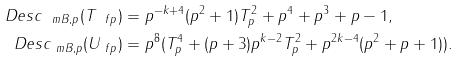<formula> <loc_0><loc_0><loc_500><loc_500>\ D e s c _ { \ m B , p } ( T _ { \ f p } ) & = p ^ { - k + 4 } ( p ^ { 2 } + 1 ) T _ { p } ^ { 2 } + p ^ { 4 } + p ^ { 3 } + p - 1 , \\ \ D e s c _ { \ m B , p } ( U _ { \ f p } ) & = p ^ { 8 } ( T _ { p } ^ { 4 } + ( p + 3 ) p ^ { k - 2 } T _ { p } ^ { 2 } + p ^ { 2 k - 4 } ( p ^ { 2 } + p + 1 ) ) .</formula> 